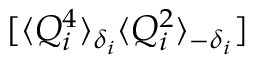<formula> <loc_0><loc_0><loc_500><loc_500>[ \langle Q _ { i } ^ { 4 } \rangle _ { \delta _ { i } } \langle Q _ { i } ^ { 2 } \rangle _ { - \delta _ { i } } ]</formula> 